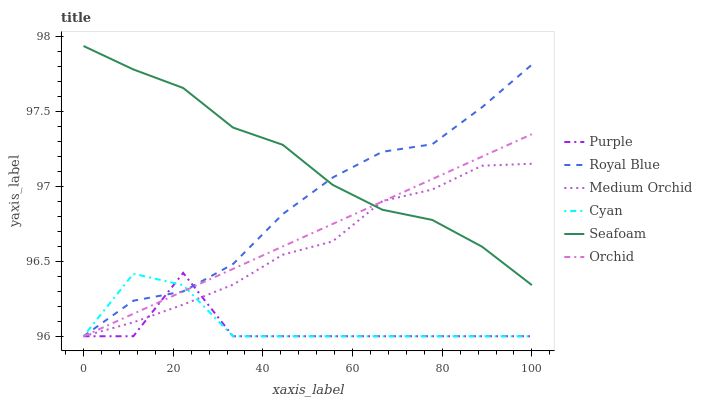Does Medium Orchid have the minimum area under the curve?
Answer yes or no. No. Does Medium Orchid have the maximum area under the curve?
Answer yes or no. No. Is Medium Orchid the smoothest?
Answer yes or no. No. Is Medium Orchid the roughest?
Answer yes or no. No. Does Seafoam have the lowest value?
Answer yes or no. No. Does Medium Orchid have the highest value?
Answer yes or no. No. Is Cyan less than Seafoam?
Answer yes or no. Yes. Is Seafoam greater than Cyan?
Answer yes or no. Yes. Does Cyan intersect Seafoam?
Answer yes or no. No. 